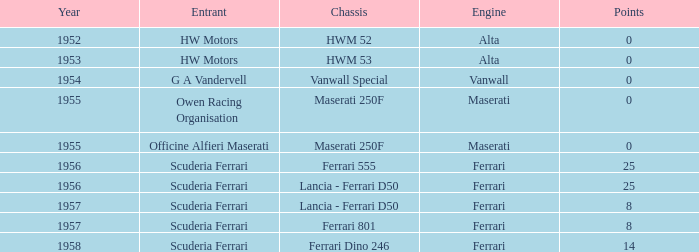When there were 8 points, which firm was responsible for creating the chassis? Lancia - Ferrari D50, Ferrari 801. 